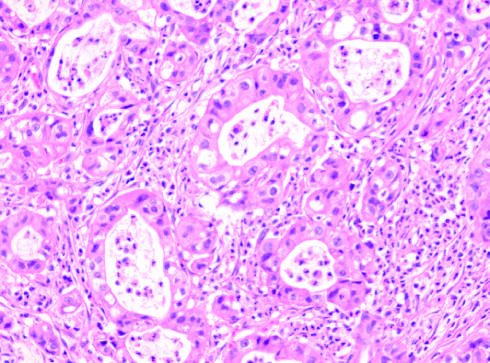does darker trabeculae have the same appearance as that of intrahepatic cholangiocarcinoma?
Answer the question using a single word or phrase. No 